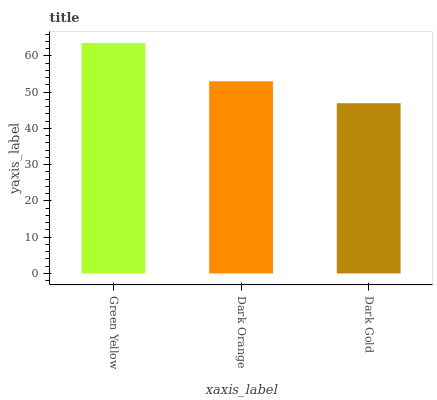Is Dark Gold the minimum?
Answer yes or no. Yes. Is Green Yellow the maximum?
Answer yes or no. Yes. Is Dark Orange the minimum?
Answer yes or no. No. Is Dark Orange the maximum?
Answer yes or no. No. Is Green Yellow greater than Dark Orange?
Answer yes or no. Yes. Is Dark Orange less than Green Yellow?
Answer yes or no. Yes. Is Dark Orange greater than Green Yellow?
Answer yes or no. No. Is Green Yellow less than Dark Orange?
Answer yes or no. No. Is Dark Orange the high median?
Answer yes or no. Yes. Is Dark Orange the low median?
Answer yes or no. Yes. Is Green Yellow the high median?
Answer yes or no. No. Is Dark Gold the low median?
Answer yes or no. No. 